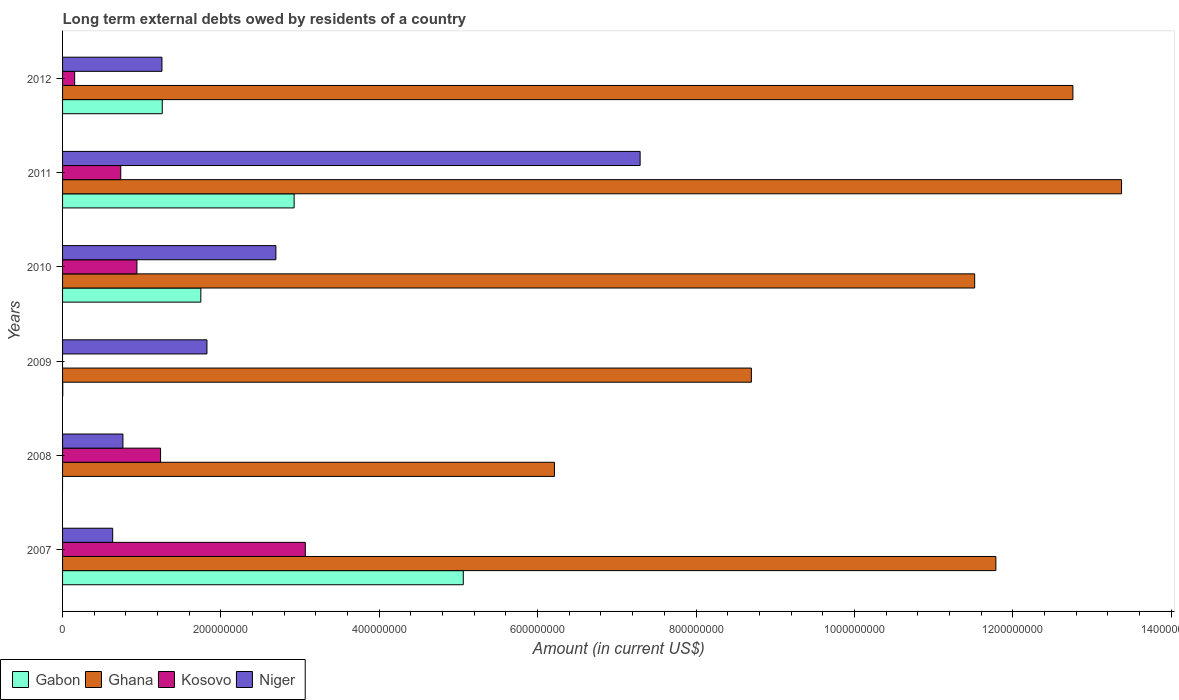How many different coloured bars are there?
Give a very brief answer. 4. Are the number of bars per tick equal to the number of legend labels?
Your answer should be compact. No. Are the number of bars on each tick of the Y-axis equal?
Your response must be concise. No. What is the label of the 5th group of bars from the top?
Offer a very short reply. 2008. What is the amount of long-term external debts owed by residents in Ghana in 2007?
Keep it short and to the point. 1.18e+09. Across all years, what is the maximum amount of long-term external debts owed by residents in Niger?
Your answer should be very brief. 7.29e+08. Across all years, what is the minimum amount of long-term external debts owed by residents in Ghana?
Give a very brief answer. 6.21e+08. What is the total amount of long-term external debts owed by residents in Ghana in the graph?
Offer a terse response. 6.44e+09. What is the difference between the amount of long-term external debts owed by residents in Gabon in 2011 and that in 2012?
Provide a succinct answer. 1.67e+08. What is the difference between the amount of long-term external debts owed by residents in Niger in 2008 and the amount of long-term external debts owed by residents in Ghana in 2007?
Make the answer very short. -1.10e+09. What is the average amount of long-term external debts owed by residents in Ghana per year?
Give a very brief answer. 1.07e+09. In the year 2010, what is the difference between the amount of long-term external debts owed by residents in Ghana and amount of long-term external debts owed by residents in Gabon?
Your answer should be very brief. 9.77e+08. In how many years, is the amount of long-term external debts owed by residents in Kosovo greater than 1120000000 US$?
Give a very brief answer. 0. What is the ratio of the amount of long-term external debts owed by residents in Kosovo in 2010 to that in 2012?
Make the answer very short. 6.14. Is the difference between the amount of long-term external debts owed by residents in Ghana in 2007 and 2010 greater than the difference between the amount of long-term external debts owed by residents in Gabon in 2007 and 2010?
Your answer should be compact. No. What is the difference between the highest and the second highest amount of long-term external debts owed by residents in Kosovo?
Provide a short and direct response. 1.83e+08. What is the difference between the highest and the lowest amount of long-term external debts owed by residents in Kosovo?
Give a very brief answer. 3.07e+08. In how many years, is the amount of long-term external debts owed by residents in Gabon greater than the average amount of long-term external debts owed by residents in Gabon taken over all years?
Give a very brief answer. 2. Is the sum of the amount of long-term external debts owed by residents in Ghana in 2010 and 2011 greater than the maximum amount of long-term external debts owed by residents in Gabon across all years?
Your answer should be very brief. Yes. Is it the case that in every year, the sum of the amount of long-term external debts owed by residents in Ghana and amount of long-term external debts owed by residents in Gabon is greater than the sum of amount of long-term external debts owed by residents in Niger and amount of long-term external debts owed by residents in Kosovo?
Make the answer very short. No. Is it the case that in every year, the sum of the amount of long-term external debts owed by residents in Niger and amount of long-term external debts owed by residents in Kosovo is greater than the amount of long-term external debts owed by residents in Gabon?
Your response must be concise. No. How many years are there in the graph?
Offer a terse response. 6. How many legend labels are there?
Keep it short and to the point. 4. How are the legend labels stacked?
Give a very brief answer. Horizontal. What is the title of the graph?
Keep it short and to the point. Long term external debts owed by residents of a country. Does "China" appear as one of the legend labels in the graph?
Your response must be concise. No. What is the label or title of the X-axis?
Provide a succinct answer. Amount (in current US$). What is the Amount (in current US$) in Gabon in 2007?
Provide a succinct answer. 5.06e+08. What is the Amount (in current US$) in Ghana in 2007?
Your answer should be very brief. 1.18e+09. What is the Amount (in current US$) in Kosovo in 2007?
Provide a succinct answer. 3.07e+08. What is the Amount (in current US$) in Niger in 2007?
Ensure brevity in your answer.  6.33e+07. What is the Amount (in current US$) of Ghana in 2008?
Make the answer very short. 6.21e+08. What is the Amount (in current US$) of Kosovo in 2008?
Give a very brief answer. 1.24e+08. What is the Amount (in current US$) of Niger in 2008?
Keep it short and to the point. 7.62e+07. What is the Amount (in current US$) in Gabon in 2009?
Offer a terse response. 2.35e+05. What is the Amount (in current US$) of Ghana in 2009?
Your answer should be compact. 8.70e+08. What is the Amount (in current US$) in Kosovo in 2009?
Offer a very short reply. 0. What is the Amount (in current US$) in Niger in 2009?
Keep it short and to the point. 1.82e+08. What is the Amount (in current US$) in Gabon in 2010?
Your answer should be compact. 1.75e+08. What is the Amount (in current US$) in Ghana in 2010?
Your answer should be compact. 1.15e+09. What is the Amount (in current US$) in Kosovo in 2010?
Provide a succinct answer. 9.39e+07. What is the Amount (in current US$) of Niger in 2010?
Your answer should be compact. 2.69e+08. What is the Amount (in current US$) of Gabon in 2011?
Provide a succinct answer. 2.92e+08. What is the Amount (in current US$) of Ghana in 2011?
Your response must be concise. 1.34e+09. What is the Amount (in current US$) in Kosovo in 2011?
Give a very brief answer. 7.35e+07. What is the Amount (in current US$) in Niger in 2011?
Offer a very short reply. 7.29e+08. What is the Amount (in current US$) of Gabon in 2012?
Your answer should be very brief. 1.26e+08. What is the Amount (in current US$) of Ghana in 2012?
Make the answer very short. 1.28e+09. What is the Amount (in current US$) in Kosovo in 2012?
Offer a terse response. 1.53e+07. What is the Amount (in current US$) in Niger in 2012?
Make the answer very short. 1.26e+08. Across all years, what is the maximum Amount (in current US$) of Gabon?
Your answer should be compact. 5.06e+08. Across all years, what is the maximum Amount (in current US$) of Ghana?
Ensure brevity in your answer.  1.34e+09. Across all years, what is the maximum Amount (in current US$) of Kosovo?
Offer a very short reply. 3.07e+08. Across all years, what is the maximum Amount (in current US$) of Niger?
Offer a very short reply. 7.29e+08. Across all years, what is the minimum Amount (in current US$) of Gabon?
Your response must be concise. 0. Across all years, what is the minimum Amount (in current US$) of Ghana?
Provide a short and direct response. 6.21e+08. Across all years, what is the minimum Amount (in current US$) in Kosovo?
Offer a terse response. 0. Across all years, what is the minimum Amount (in current US$) in Niger?
Keep it short and to the point. 6.33e+07. What is the total Amount (in current US$) of Gabon in the graph?
Your answer should be compact. 1.10e+09. What is the total Amount (in current US$) of Ghana in the graph?
Offer a terse response. 6.44e+09. What is the total Amount (in current US$) of Kosovo in the graph?
Ensure brevity in your answer.  6.13e+08. What is the total Amount (in current US$) in Niger in the graph?
Give a very brief answer. 1.45e+09. What is the difference between the Amount (in current US$) of Ghana in 2007 and that in 2008?
Make the answer very short. 5.57e+08. What is the difference between the Amount (in current US$) in Kosovo in 2007 and that in 2008?
Keep it short and to the point. 1.83e+08. What is the difference between the Amount (in current US$) in Niger in 2007 and that in 2008?
Keep it short and to the point. -1.29e+07. What is the difference between the Amount (in current US$) of Gabon in 2007 and that in 2009?
Provide a succinct answer. 5.06e+08. What is the difference between the Amount (in current US$) of Ghana in 2007 and that in 2009?
Provide a succinct answer. 3.09e+08. What is the difference between the Amount (in current US$) of Niger in 2007 and that in 2009?
Offer a terse response. -1.19e+08. What is the difference between the Amount (in current US$) of Gabon in 2007 and that in 2010?
Keep it short and to the point. 3.31e+08. What is the difference between the Amount (in current US$) in Ghana in 2007 and that in 2010?
Ensure brevity in your answer.  2.68e+07. What is the difference between the Amount (in current US$) of Kosovo in 2007 and that in 2010?
Offer a very short reply. 2.13e+08. What is the difference between the Amount (in current US$) of Niger in 2007 and that in 2010?
Offer a very short reply. -2.06e+08. What is the difference between the Amount (in current US$) in Gabon in 2007 and that in 2011?
Make the answer very short. 2.14e+08. What is the difference between the Amount (in current US$) in Ghana in 2007 and that in 2011?
Provide a succinct answer. -1.59e+08. What is the difference between the Amount (in current US$) in Kosovo in 2007 and that in 2011?
Ensure brevity in your answer.  2.33e+08. What is the difference between the Amount (in current US$) in Niger in 2007 and that in 2011?
Make the answer very short. -6.66e+08. What is the difference between the Amount (in current US$) in Gabon in 2007 and that in 2012?
Give a very brief answer. 3.80e+08. What is the difference between the Amount (in current US$) in Ghana in 2007 and that in 2012?
Offer a terse response. -9.73e+07. What is the difference between the Amount (in current US$) in Kosovo in 2007 and that in 2012?
Your answer should be compact. 2.91e+08. What is the difference between the Amount (in current US$) of Niger in 2007 and that in 2012?
Your response must be concise. -6.22e+07. What is the difference between the Amount (in current US$) of Ghana in 2008 and that in 2009?
Offer a very short reply. -2.49e+08. What is the difference between the Amount (in current US$) in Niger in 2008 and that in 2009?
Provide a succinct answer. -1.06e+08. What is the difference between the Amount (in current US$) of Ghana in 2008 and that in 2010?
Provide a succinct answer. -5.31e+08. What is the difference between the Amount (in current US$) in Kosovo in 2008 and that in 2010?
Provide a succinct answer. 2.99e+07. What is the difference between the Amount (in current US$) in Niger in 2008 and that in 2010?
Give a very brief answer. -1.93e+08. What is the difference between the Amount (in current US$) in Ghana in 2008 and that in 2011?
Ensure brevity in your answer.  -7.16e+08. What is the difference between the Amount (in current US$) of Kosovo in 2008 and that in 2011?
Your answer should be very brief. 5.03e+07. What is the difference between the Amount (in current US$) in Niger in 2008 and that in 2011?
Offer a terse response. -6.53e+08. What is the difference between the Amount (in current US$) of Ghana in 2008 and that in 2012?
Offer a very short reply. -6.55e+08. What is the difference between the Amount (in current US$) of Kosovo in 2008 and that in 2012?
Ensure brevity in your answer.  1.08e+08. What is the difference between the Amount (in current US$) in Niger in 2008 and that in 2012?
Give a very brief answer. -4.93e+07. What is the difference between the Amount (in current US$) in Gabon in 2009 and that in 2010?
Make the answer very short. -1.74e+08. What is the difference between the Amount (in current US$) in Ghana in 2009 and that in 2010?
Keep it short and to the point. -2.82e+08. What is the difference between the Amount (in current US$) in Niger in 2009 and that in 2010?
Offer a terse response. -8.71e+07. What is the difference between the Amount (in current US$) in Gabon in 2009 and that in 2011?
Give a very brief answer. -2.92e+08. What is the difference between the Amount (in current US$) in Ghana in 2009 and that in 2011?
Your response must be concise. -4.68e+08. What is the difference between the Amount (in current US$) of Niger in 2009 and that in 2011?
Offer a terse response. -5.47e+08. What is the difference between the Amount (in current US$) in Gabon in 2009 and that in 2012?
Your response must be concise. -1.26e+08. What is the difference between the Amount (in current US$) in Ghana in 2009 and that in 2012?
Provide a short and direct response. -4.06e+08. What is the difference between the Amount (in current US$) in Niger in 2009 and that in 2012?
Your response must be concise. 5.68e+07. What is the difference between the Amount (in current US$) in Gabon in 2010 and that in 2011?
Your response must be concise. -1.18e+08. What is the difference between the Amount (in current US$) in Ghana in 2010 and that in 2011?
Provide a short and direct response. -1.85e+08. What is the difference between the Amount (in current US$) of Kosovo in 2010 and that in 2011?
Provide a succinct answer. 2.04e+07. What is the difference between the Amount (in current US$) in Niger in 2010 and that in 2011?
Provide a succinct answer. -4.60e+08. What is the difference between the Amount (in current US$) of Gabon in 2010 and that in 2012?
Offer a very short reply. 4.87e+07. What is the difference between the Amount (in current US$) in Ghana in 2010 and that in 2012?
Keep it short and to the point. -1.24e+08. What is the difference between the Amount (in current US$) in Kosovo in 2010 and that in 2012?
Provide a succinct answer. 7.86e+07. What is the difference between the Amount (in current US$) in Niger in 2010 and that in 2012?
Offer a terse response. 1.44e+08. What is the difference between the Amount (in current US$) of Gabon in 2011 and that in 2012?
Ensure brevity in your answer.  1.67e+08. What is the difference between the Amount (in current US$) of Ghana in 2011 and that in 2012?
Make the answer very short. 6.14e+07. What is the difference between the Amount (in current US$) of Kosovo in 2011 and that in 2012?
Your response must be concise. 5.82e+07. What is the difference between the Amount (in current US$) of Niger in 2011 and that in 2012?
Keep it short and to the point. 6.04e+08. What is the difference between the Amount (in current US$) of Gabon in 2007 and the Amount (in current US$) of Ghana in 2008?
Make the answer very short. -1.15e+08. What is the difference between the Amount (in current US$) of Gabon in 2007 and the Amount (in current US$) of Kosovo in 2008?
Your answer should be compact. 3.82e+08. What is the difference between the Amount (in current US$) of Gabon in 2007 and the Amount (in current US$) of Niger in 2008?
Make the answer very short. 4.30e+08. What is the difference between the Amount (in current US$) of Ghana in 2007 and the Amount (in current US$) of Kosovo in 2008?
Your response must be concise. 1.05e+09. What is the difference between the Amount (in current US$) in Ghana in 2007 and the Amount (in current US$) in Niger in 2008?
Make the answer very short. 1.10e+09. What is the difference between the Amount (in current US$) in Kosovo in 2007 and the Amount (in current US$) in Niger in 2008?
Your answer should be compact. 2.30e+08. What is the difference between the Amount (in current US$) in Gabon in 2007 and the Amount (in current US$) in Ghana in 2009?
Make the answer very short. -3.64e+08. What is the difference between the Amount (in current US$) in Gabon in 2007 and the Amount (in current US$) in Niger in 2009?
Provide a short and direct response. 3.24e+08. What is the difference between the Amount (in current US$) of Ghana in 2007 and the Amount (in current US$) of Niger in 2009?
Make the answer very short. 9.96e+08. What is the difference between the Amount (in current US$) of Kosovo in 2007 and the Amount (in current US$) of Niger in 2009?
Provide a short and direct response. 1.24e+08. What is the difference between the Amount (in current US$) of Gabon in 2007 and the Amount (in current US$) of Ghana in 2010?
Give a very brief answer. -6.46e+08. What is the difference between the Amount (in current US$) in Gabon in 2007 and the Amount (in current US$) in Kosovo in 2010?
Provide a succinct answer. 4.12e+08. What is the difference between the Amount (in current US$) in Gabon in 2007 and the Amount (in current US$) in Niger in 2010?
Provide a succinct answer. 2.37e+08. What is the difference between the Amount (in current US$) in Ghana in 2007 and the Amount (in current US$) in Kosovo in 2010?
Provide a short and direct response. 1.08e+09. What is the difference between the Amount (in current US$) in Ghana in 2007 and the Amount (in current US$) in Niger in 2010?
Provide a short and direct response. 9.09e+08. What is the difference between the Amount (in current US$) in Kosovo in 2007 and the Amount (in current US$) in Niger in 2010?
Offer a very short reply. 3.72e+07. What is the difference between the Amount (in current US$) of Gabon in 2007 and the Amount (in current US$) of Ghana in 2011?
Provide a succinct answer. -8.31e+08. What is the difference between the Amount (in current US$) in Gabon in 2007 and the Amount (in current US$) in Kosovo in 2011?
Give a very brief answer. 4.33e+08. What is the difference between the Amount (in current US$) of Gabon in 2007 and the Amount (in current US$) of Niger in 2011?
Provide a short and direct response. -2.23e+08. What is the difference between the Amount (in current US$) of Ghana in 2007 and the Amount (in current US$) of Kosovo in 2011?
Your answer should be compact. 1.11e+09. What is the difference between the Amount (in current US$) in Ghana in 2007 and the Amount (in current US$) in Niger in 2011?
Keep it short and to the point. 4.49e+08. What is the difference between the Amount (in current US$) of Kosovo in 2007 and the Amount (in current US$) of Niger in 2011?
Give a very brief answer. -4.23e+08. What is the difference between the Amount (in current US$) of Gabon in 2007 and the Amount (in current US$) of Ghana in 2012?
Provide a short and direct response. -7.70e+08. What is the difference between the Amount (in current US$) in Gabon in 2007 and the Amount (in current US$) in Kosovo in 2012?
Ensure brevity in your answer.  4.91e+08. What is the difference between the Amount (in current US$) of Gabon in 2007 and the Amount (in current US$) of Niger in 2012?
Your response must be concise. 3.81e+08. What is the difference between the Amount (in current US$) in Ghana in 2007 and the Amount (in current US$) in Kosovo in 2012?
Provide a succinct answer. 1.16e+09. What is the difference between the Amount (in current US$) of Ghana in 2007 and the Amount (in current US$) of Niger in 2012?
Offer a terse response. 1.05e+09. What is the difference between the Amount (in current US$) of Kosovo in 2007 and the Amount (in current US$) of Niger in 2012?
Make the answer very short. 1.81e+08. What is the difference between the Amount (in current US$) in Ghana in 2008 and the Amount (in current US$) in Niger in 2009?
Your answer should be compact. 4.39e+08. What is the difference between the Amount (in current US$) in Kosovo in 2008 and the Amount (in current US$) in Niger in 2009?
Your answer should be very brief. -5.86e+07. What is the difference between the Amount (in current US$) of Ghana in 2008 and the Amount (in current US$) of Kosovo in 2010?
Offer a very short reply. 5.27e+08. What is the difference between the Amount (in current US$) in Ghana in 2008 and the Amount (in current US$) in Niger in 2010?
Offer a very short reply. 3.52e+08. What is the difference between the Amount (in current US$) of Kosovo in 2008 and the Amount (in current US$) of Niger in 2010?
Give a very brief answer. -1.46e+08. What is the difference between the Amount (in current US$) of Ghana in 2008 and the Amount (in current US$) of Kosovo in 2011?
Your answer should be very brief. 5.48e+08. What is the difference between the Amount (in current US$) of Ghana in 2008 and the Amount (in current US$) of Niger in 2011?
Give a very brief answer. -1.08e+08. What is the difference between the Amount (in current US$) in Kosovo in 2008 and the Amount (in current US$) in Niger in 2011?
Provide a short and direct response. -6.06e+08. What is the difference between the Amount (in current US$) of Ghana in 2008 and the Amount (in current US$) of Kosovo in 2012?
Your answer should be compact. 6.06e+08. What is the difference between the Amount (in current US$) in Ghana in 2008 and the Amount (in current US$) in Niger in 2012?
Ensure brevity in your answer.  4.96e+08. What is the difference between the Amount (in current US$) of Kosovo in 2008 and the Amount (in current US$) of Niger in 2012?
Provide a short and direct response. -1.74e+06. What is the difference between the Amount (in current US$) of Gabon in 2009 and the Amount (in current US$) of Ghana in 2010?
Give a very brief answer. -1.15e+09. What is the difference between the Amount (in current US$) in Gabon in 2009 and the Amount (in current US$) in Kosovo in 2010?
Provide a short and direct response. -9.37e+07. What is the difference between the Amount (in current US$) of Gabon in 2009 and the Amount (in current US$) of Niger in 2010?
Give a very brief answer. -2.69e+08. What is the difference between the Amount (in current US$) in Ghana in 2009 and the Amount (in current US$) in Kosovo in 2010?
Offer a very short reply. 7.76e+08. What is the difference between the Amount (in current US$) in Ghana in 2009 and the Amount (in current US$) in Niger in 2010?
Offer a terse response. 6.01e+08. What is the difference between the Amount (in current US$) in Gabon in 2009 and the Amount (in current US$) in Ghana in 2011?
Offer a terse response. -1.34e+09. What is the difference between the Amount (in current US$) in Gabon in 2009 and the Amount (in current US$) in Kosovo in 2011?
Your answer should be very brief. -7.32e+07. What is the difference between the Amount (in current US$) in Gabon in 2009 and the Amount (in current US$) in Niger in 2011?
Your answer should be very brief. -7.29e+08. What is the difference between the Amount (in current US$) in Ghana in 2009 and the Amount (in current US$) in Kosovo in 2011?
Provide a succinct answer. 7.96e+08. What is the difference between the Amount (in current US$) in Ghana in 2009 and the Amount (in current US$) in Niger in 2011?
Keep it short and to the point. 1.40e+08. What is the difference between the Amount (in current US$) in Gabon in 2009 and the Amount (in current US$) in Ghana in 2012?
Give a very brief answer. -1.28e+09. What is the difference between the Amount (in current US$) of Gabon in 2009 and the Amount (in current US$) of Kosovo in 2012?
Provide a short and direct response. -1.51e+07. What is the difference between the Amount (in current US$) in Gabon in 2009 and the Amount (in current US$) in Niger in 2012?
Offer a terse response. -1.25e+08. What is the difference between the Amount (in current US$) of Ghana in 2009 and the Amount (in current US$) of Kosovo in 2012?
Make the answer very short. 8.55e+08. What is the difference between the Amount (in current US$) of Ghana in 2009 and the Amount (in current US$) of Niger in 2012?
Offer a terse response. 7.44e+08. What is the difference between the Amount (in current US$) of Gabon in 2010 and the Amount (in current US$) of Ghana in 2011?
Offer a very short reply. -1.16e+09. What is the difference between the Amount (in current US$) of Gabon in 2010 and the Amount (in current US$) of Kosovo in 2011?
Your response must be concise. 1.01e+08. What is the difference between the Amount (in current US$) in Gabon in 2010 and the Amount (in current US$) in Niger in 2011?
Keep it short and to the point. -5.55e+08. What is the difference between the Amount (in current US$) in Ghana in 2010 and the Amount (in current US$) in Kosovo in 2011?
Your response must be concise. 1.08e+09. What is the difference between the Amount (in current US$) in Ghana in 2010 and the Amount (in current US$) in Niger in 2011?
Give a very brief answer. 4.23e+08. What is the difference between the Amount (in current US$) in Kosovo in 2010 and the Amount (in current US$) in Niger in 2011?
Keep it short and to the point. -6.36e+08. What is the difference between the Amount (in current US$) of Gabon in 2010 and the Amount (in current US$) of Ghana in 2012?
Your answer should be very brief. -1.10e+09. What is the difference between the Amount (in current US$) in Gabon in 2010 and the Amount (in current US$) in Kosovo in 2012?
Your response must be concise. 1.59e+08. What is the difference between the Amount (in current US$) in Gabon in 2010 and the Amount (in current US$) in Niger in 2012?
Your response must be concise. 4.91e+07. What is the difference between the Amount (in current US$) of Ghana in 2010 and the Amount (in current US$) of Kosovo in 2012?
Provide a succinct answer. 1.14e+09. What is the difference between the Amount (in current US$) of Ghana in 2010 and the Amount (in current US$) of Niger in 2012?
Give a very brief answer. 1.03e+09. What is the difference between the Amount (in current US$) of Kosovo in 2010 and the Amount (in current US$) of Niger in 2012?
Keep it short and to the point. -3.16e+07. What is the difference between the Amount (in current US$) of Gabon in 2011 and the Amount (in current US$) of Ghana in 2012?
Offer a very short reply. -9.84e+08. What is the difference between the Amount (in current US$) in Gabon in 2011 and the Amount (in current US$) in Kosovo in 2012?
Your response must be concise. 2.77e+08. What is the difference between the Amount (in current US$) of Gabon in 2011 and the Amount (in current US$) of Niger in 2012?
Make the answer very short. 1.67e+08. What is the difference between the Amount (in current US$) in Ghana in 2011 and the Amount (in current US$) in Kosovo in 2012?
Ensure brevity in your answer.  1.32e+09. What is the difference between the Amount (in current US$) in Ghana in 2011 and the Amount (in current US$) in Niger in 2012?
Ensure brevity in your answer.  1.21e+09. What is the difference between the Amount (in current US$) in Kosovo in 2011 and the Amount (in current US$) in Niger in 2012?
Provide a succinct answer. -5.20e+07. What is the average Amount (in current US$) in Gabon per year?
Keep it short and to the point. 1.83e+08. What is the average Amount (in current US$) in Ghana per year?
Give a very brief answer. 1.07e+09. What is the average Amount (in current US$) of Kosovo per year?
Give a very brief answer. 1.02e+08. What is the average Amount (in current US$) of Niger per year?
Give a very brief answer. 2.41e+08. In the year 2007, what is the difference between the Amount (in current US$) of Gabon and Amount (in current US$) of Ghana?
Your response must be concise. -6.73e+08. In the year 2007, what is the difference between the Amount (in current US$) of Gabon and Amount (in current US$) of Kosovo?
Make the answer very short. 2.00e+08. In the year 2007, what is the difference between the Amount (in current US$) in Gabon and Amount (in current US$) in Niger?
Ensure brevity in your answer.  4.43e+08. In the year 2007, what is the difference between the Amount (in current US$) of Ghana and Amount (in current US$) of Kosovo?
Make the answer very short. 8.72e+08. In the year 2007, what is the difference between the Amount (in current US$) of Ghana and Amount (in current US$) of Niger?
Your answer should be very brief. 1.12e+09. In the year 2007, what is the difference between the Amount (in current US$) in Kosovo and Amount (in current US$) in Niger?
Keep it short and to the point. 2.43e+08. In the year 2008, what is the difference between the Amount (in current US$) in Ghana and Amount (in current US$) in Kosovo?
Make the answer very short. 4.97e+08. In the year 2008, what is the difference between the Amount (in current US$) of Ghana and Amount (in current US$) of Niger?
Offer a terse response. 5.45e+08. In the year 2008, what is the difference between the Amount (in current US$) in Kosovo and Amount (in current US$) in Niger?
Make the answer very short. 4.75e+07. In the year 2009, what is the difference between the Amount (in current US$) in Gabon and Amount (in current US$) in Ghana?
Your response must be concise. -8.70e+08. In the year 2009, what is the difference between the Amount (in current US$) of Gabon and Amount (in current US$) of Niger?
Provide a short and direct response. -1.82e+08. In the year 2009, what is the difference between the Amount (in current US$) of Ghana and Amount (in current US$) of Niger?
Offer a terse response. 6.88e+08. In the year 2010, what is the difference between the Amount (in current US$) of Gabon and Amount (in current US$) of Ghana?
Your answer should be compact. -9.77e+08. In the year 2010, what is the difference between the Amount (in current US$) in Gabon and Amount (in current US$) in Kosovo?
Offer a terse response. 8.07e+07. In the year 2010, what is the difference between the Amount (in current US$) of Gabon and Amount (in current US$) of Niger?
Offer a very short reply. -9.48e+07. In the year 2010, what is the difference between the Amount (in current US$) of Ghana and Amount (in current US$) of Kosovo?
Your response must be concise. 1.06e+09. In the year 2010, what is the difference between the Amount (in current US$) of Ghana and Amount (in current US$) of Niger?
Your response must be concise. 8.83e+08. In the year 2010, what is the difference between the Amount (in current US$) in Kosovo and Amount (in current US$) in Niger?
Provide a succinct answer. -1.75e+08. In the year 2011, what is the difference between the Amount (in current US$) in Gabon and Amount (in current US$) in Ghana?
Make the answer very short. -1.04e+09. In the year 2011, what is the difference between the Amount (in current US$) in Gabon and Amount (in current US$) in Kosovo?
Offer a very short reply. 2.19e+08. In the year 2011, what is the difference between the Amount (in current US$) of Gabon and Amount (in current US$) of Niger?
Make the answer very short. -4.37e+08. In the year 2011, what is the difference between the Amount (in current US$) in Ghana and Amount (in current US$) in Kosovo?
Ensure brevity in your answer.  1.26e+09. In the year 2011, what is the difference between the Amount (in current US$) in Ghana and Amount (in current US$) in Niger?
Offer a terse response. 6.08e+08. In the year 2011, what is the difference between the Amount (in current US$) of Kosovo and Amount (in current US$) of Niger?
Your answer should be compact. -6.56e+08. In the year 2012, what is the difference between the Amount (in current US$) of Gabon and Amount (in current US$) of Ghana?
Provide a short and direct response. -1.15e+09. In the year 2012, what is the difference between the Amount (in current US$) in Gabon and Amount (in current US$) in Kosovo?
Keep it short and to the point. 1.11e+08. In the year 2012, what is the difference between the Amount (in current US$) in Gabon and Amount (in current US$) in Niger?
Make the answer very short. 4.11e+05. In the year 2012, what is the difference between the Amount (in current US$) of Ghana and Amount (in current US$) of Kosovo?
Your answer should be very brief. 1.26e+09. In the year 2012, what is the difference between the Amount (in current US$) of Ghana and Amount (in current US$) of Niger?
Give a very brief answer. 1.15e+09. In the year 2012, what is the difference between the Amount (in current US$) of Kosovo and Amount (in current US$) of Niger?
Your answer should be very brief. -1.10e+08. What is the ratio of the Amount (in current US$) of Ghana in 2007 to that in 2008?
Provide a short and direct response. 1.9. What is the ratio of the Amount (in current US$) in Kosovo in 2007 to that in 2008?
Your answer should be very brief. 2.48. What is the ratio of the Amount (in current US$) in Niger in 2007 to that in 2008?
Offer a terse response. 0.83. What is the ratio of the Amount (in current US$) of Gabon in 2007 to that in 2009?
Your response must be concise. 2153.56. What is the ratio of the Amount (in current US$) in Ghana in 2007 to that in 2009?
Give a very brief answer. 1.35. What is the ratio of the Amount (in current US$) of Niger in 2007 to that in 2009?
Your answer should be very brief. 0.35. What is the ratio of the Amount (in current US$) in Gabon in 2007 to that in 2010?
Give a very brief answer. 2.9. What is the ratio of the Amount (in current US$) in Ghana in 2007 to that in 2010?
Offer a terse response. 1.02. What is the ratio of the Amount (in current US$) in Kosovo in 2007 to that in 2010?
Provide a succinct answer. 3.26. What is the ratio of the Amount (in current US$) in Niger in 2007 to that in 2010?
Offer a terse response. 0.23. What is the ratio of the Amount (in current US$) of Gabon in 2007 to that in 2011?
Give a very brief answer. 1.73. What is the ratio of the Amount (in current US$) in Ghana in 2007 to that in 2011?
Keep it short and to the point. 0.88. What is the ratio of the Amount (in current US$) in Kosovo in 2007 to that in 2011?
Make the answer very short. 4.17. What is the ratio of the Amount (in current US$) in Niger in 2007 to that in 2011?
Provide a succinct answer. 0.09. What is the ratio of the Amount (in current US$) in Gabon in 2007 to that in 2012?
Ensure brevity in your answer.  4.02. What is the ratio of the Amount (in current US$) in Ghana in 2007 to that in 2012?
Your answer should be compact. 0.92. What is the ratio of the Amount (in current US$) of Kosovo in 2007 to that in 2012?
Provide a succinct answer. 20.04. What is the ratio of the Amount (in current US$) of Niger in 2007 to that in 2012?
Offer a terse response. 0.5. What is the ratio of the Amount (in current US$) in Ghana in 2008 to that in 2009?
Keep it short and to the point. 0.71. What is the ratio of the Amount (in current US$) in Niger in 2008 to that in 2009?
Your answer should be compact. 0.42. What is the ratio of the Amount (in current US$) of Ghana in 2008 to that in 2010?
Ensure brevity in your answer.  0.54. What is the ratio of the Amount (in current US$) in Kosovo in 2008 to that in 2010?
Make the answer very short. 1.32. What is the ratio of the Amount (in current US$) in Niger in 2008 to that in 2010?
Provide a short and direct response. 0.28. What is the ratio of the Amount (in current US$) in Ghana in 2008 to that in 2011?
Offer a very short reply. 0.46. What is the ratio of the Amount (in current US$) in Kosovo in 2008 to that in 2011?
Give a very brief answer. 1.68. What is the ratio of the Amount (in current US$) of Niger in 2008 to that in 2011?
Your answer should be very brief. 0.1. What is the ratio of the Amount (in current US$) in Ghana in 2008 to that in 2012?
Keep it short and to the point. 0.49. What is the ratio of the Amount (in current US$) of Kosovo in 2008 to that in 2012?
Keep it short and to the point. 8.09. What is the ratio of the Amount (in current US$) of Niger in 2008 to that in 2012?
Offer a very short reply. 0.61. What is the ratio of the Amount (in current US$) in Gabon in 2009 to that in 2010?
Your answer should be very brief. 0. What is the ratio of the Amount (in current US$) of Ghana in 2009 to that in 2010?
Your answer should be compact. 0.76. What is the ratio of the Amount (in current US$) in Niger in 2009 to that in 2010?
Your answer should be compact. 0.68. What is the ratio of the Amount (in current US$) of Gabon in 2009 to that in 2011?
Your answer should be very brief. 0. What is the ratio of the Amount (in current US$) of Ghana in 2009 to that in 2011?
Your answer should be compact. 0.65. What is the ratio of the Amount (in current US$) of Gabon in 2009 to that in 2012?
Provide a succinct answer. 0. What is the ratio of the Amount (in current US$) in Ghana in 2009 to that in 2012?
Your answer should be compact. 0.68. What is the ratio of the Amount (in current US$) in Niger in 2009 to that in 2012?
Offer a terse response. 1.45. What is the ratio of the Amount (in current US$) of Gabon in 2010 to that in 2011?
Offer a terse response. 0.6. What is the ratio of the Amount (in current US$) in Ghana in 2010 to that in 2011?
Your response must be concise. 0.86. What is the ratio of the Amount (in current US$) in Kosovo in 2010 to that in 2011?
Offer a terse response. 1.28. What is the ratio of the Amount (in current US$) in Niger in 2010 to that in 2011?
Offer a terse response. 0.37. What is the ratio of the Amount (in current US$) in Gabon in 2010 to that in 2012?
Offer a very short reply. 1.39. What is the ratio of the Amount (in current US$) in Ghana in 2010 to that in 2012?
Your answer should be very brief. 0.9. What is the ratio of the Amount (in current US$) in Kosovo in 2010 to that in 2012?
Keep it short and to the point. 6.14. What is the ratio of the Amount (in current US$) in Niger in 2010 to that in 2012?
Keep it short and to the point. 2.15. What is the ratio of the Amount (in current US$) in Gabon in 2011 to that in 2012?
Give a very brief answer. 2.32. What is the ratio of the Amount (in current US$) in Ghana in 2011 to that in 2012?
Provide a succinct answer. 1.05. What is the ratio of the Amount (in current US$) in Kosovo in 2011 to that in 2012?
Your answer should be very brief. 4.8. What is the ratio of the Amount (in current US$) of Niger in 2011 to that in 2012?
Your response must be concise. 5.81. What is the difference between the highest and the second highest Amount (in current US$) of Gabon?
Offer a terse response. 2.14e+08. What is the difference between the highest and the second highest Amount (in current US$) in Ghana?
Keep it short and to the point. 6.14e+07. What is the difference between the highest and the second highest Amount (in current US$) of Kosovo?
Provide a short and direct response. 1.83e+08. What is the difference between the highest and the second highest Amount (in current US$) in Niger?
Your answer should be very brief. 4.60e+08. What is the difference between the highest and the lowest Amount (in current US$) in Gabon?
Provide a succinct answer. 5.06e+08. What is the difference between the highest and the lowest Amount (in current US$) of Ghana?
Ensure brevity in your answer.  7.16e+08. What is the difference between the highest and the lowest Amount (in current US$) of Kosovo?
Provide a succinct answer. 3.07e+08. What is the difference between the highest and the lowest Amount (in current US$) of Niger?
Provide a short and direct response. 6.66e+08. 